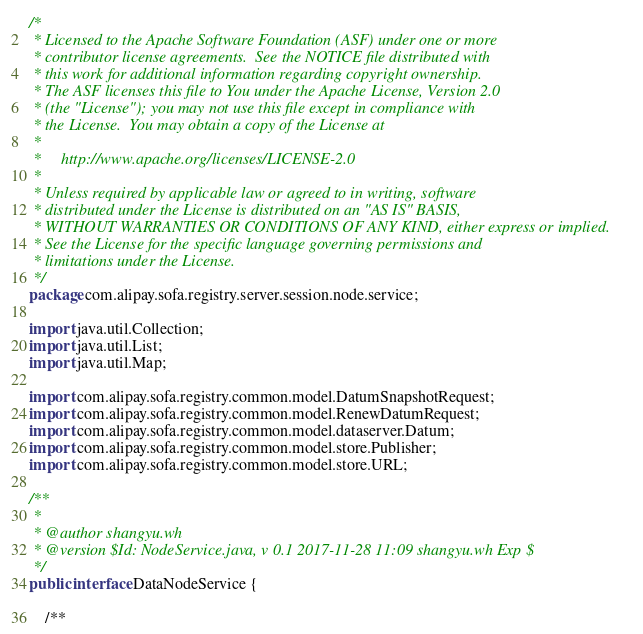Convert code to text. <code><loc_0><loc_0><loc_500><loc_500><_Java_>/*
 * Licensed to the Apache Software Foundation (ASF) under one or more
 * contributor license agreements.  See the NOTICE file distributed with
 * this work for additional information regarding copyright ownership.
 * The ASF licenses this file to You under the Apache License, Version 2.0
 * (the "License"); you may not use this file except in compliance with
 * the License.  You may obtain a copy of the License at
 *
 *     http://www.apache.org/licenses/LICENSE-2.0
 *
 * Unless required by applicable law or agreed to in writing, software
 * distributed under the License is distributed on an "AS IS" BASIS,
 * WITHOUT WARRANTIES OR CONDITIONS OF ANY KIND, either express or implied.
 * See the License for the specific language governing permissions and
 * limitations under the License.
 */
package com.alipay.sofa.registry.server.session.node.service;

import java.util.Collection;
import java.util.List;
import java.util.Map;

import com.alipay.sofa.registry.common.model.DatumSnapshotRequest;
import com.alipay.sofa.registry.common.model.RenewDatumRequest;
import com.alipay.sofa.registry.common.model.dataserver.Datum;
import com.alipay.sofa.registry.common.model.store.Publisher;
import com.alipay.sofa.registry.common.model.store.URL;

/**
 *
 * @author shangyu.wh
 * @version $Id: NodeService.java, v 0.1 2017-11-28 11:09 shangyu.wh Exp $
 */
public interface DataNodeService {

    /**</code> 